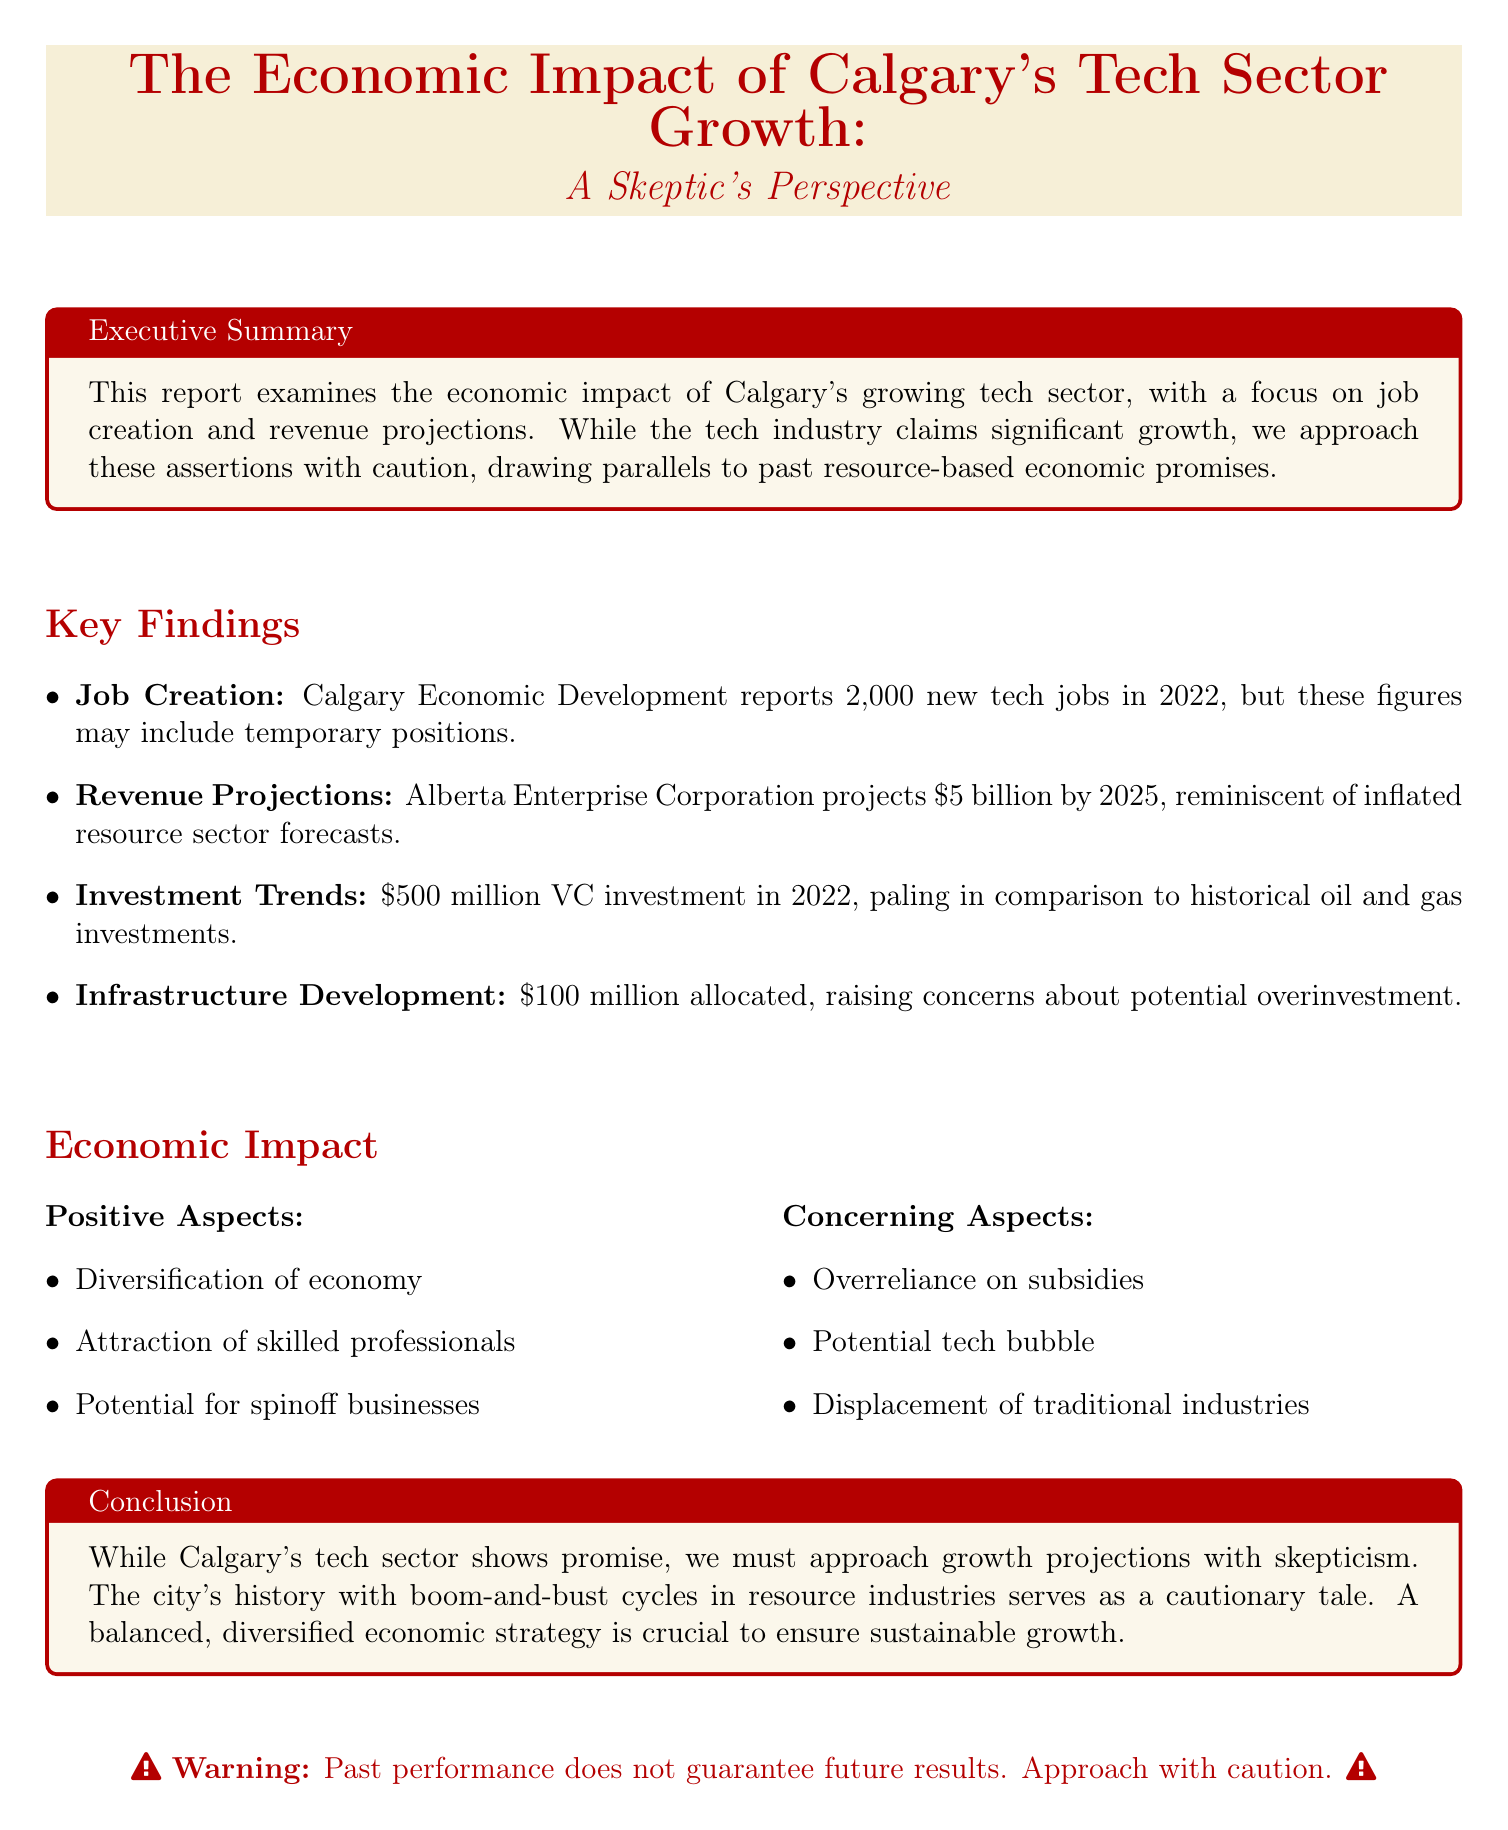What is the report title? The report title is specified in the document, indicating the focus on Calgary's tech sector growth from a skeptical view.
Answer: The Economic Impact of Calgary's Tech Sector Growth: A Skeptic's Perspective How many new tech jobs were created in 2022 according to Calgary Economic Development? The document reports the number of new tech jobs created in Calgary in 2022 as stated in the key findings.
Answer: 2,000 What is the projected revenue for the tech sector by 2025? This figure is given in the revenue projections section of the key findings, showing optimistic expectations for growth.
Answer: $5 billion What was the venture capital investment in Calgary tech startups in 2022? The document highlights the amount invested in tech startups for the year 2022, which reflects the investment trends.
Answer: $500 million What is the allocated budget for tech-focused infrastructure projects? The document details the specific amount allocated by the City of Calgary for infrastructure projects concerning the tech sector.
Answer: $100 million What are two positive aspects of the economic impact of the tech sector mentioned in the report? The document provides a breakdown of positive aspects, highlighting diversification and skilled professional attraction.
Answer: Diversification of Calgary's economy, Attraction of young, skilled professionals What does the report caution about regarding government support? This concern is noted in the concerning aspects of the economic impact section, indicating potential risks associated with government funding.
Answer: Overreliance on government subsidies and tax incentives What historical event is compared to the potential risks in Calgary's tech sector? The report draws parallels with a notable historical economic event that serves as a warning for current projections.
Answer: The dot-com crash What is the conclusion of the report regarding Calgary's tech sector growth? The conclusion summarizes the overall stance on the growth projections, emphasizing the need for skepticism.
Answer: Approach growth projections with skepticism 